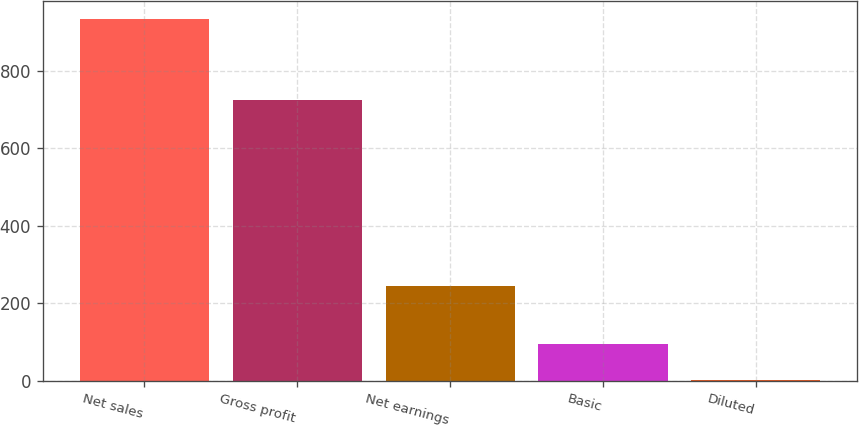Convert chart. <chart><loc_0><loc_0><loc_500><loc_500><bar_chart><fcel>Net sales<fcel>Gross profit<fcel>Net earnings<fcel>Basic<fcel>Diluted<nl><fcel>933.6<fcel>726.1<fcel>244.7<fcel>94.28<fcel>1.02<nl></chart> 